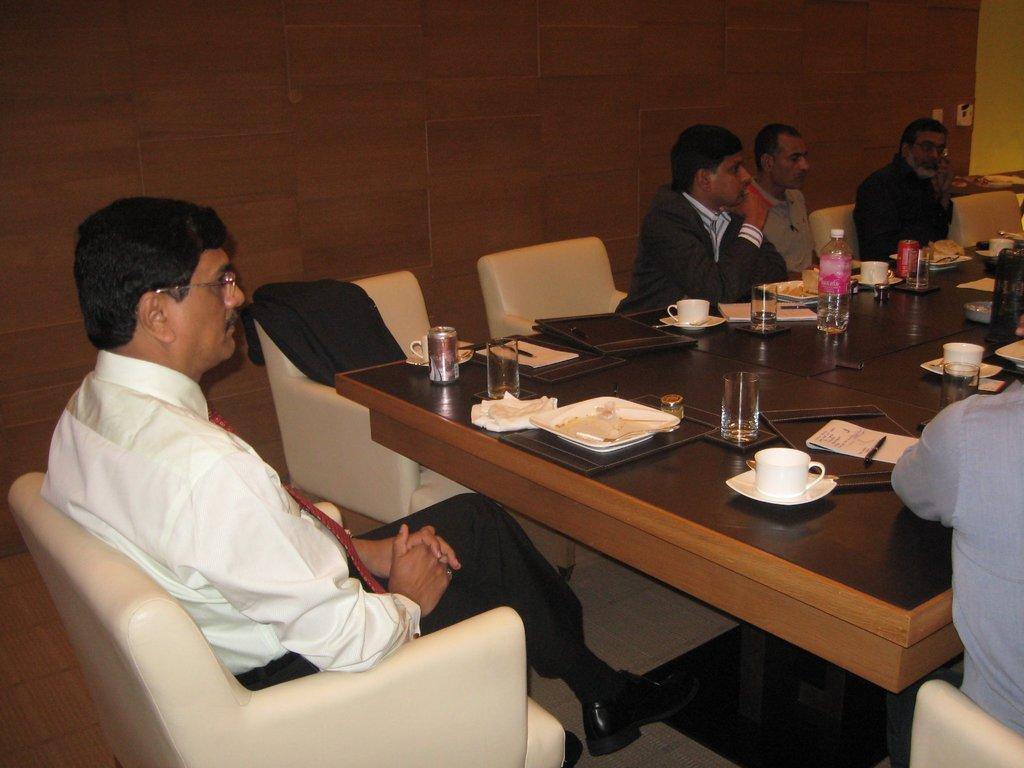Can you describe this image briefly? in this image i can see a man sitting on the chair. right to him there is a table which has cups, saucers, plates, glasses, papers, pen, water bottle and other men sitting. 